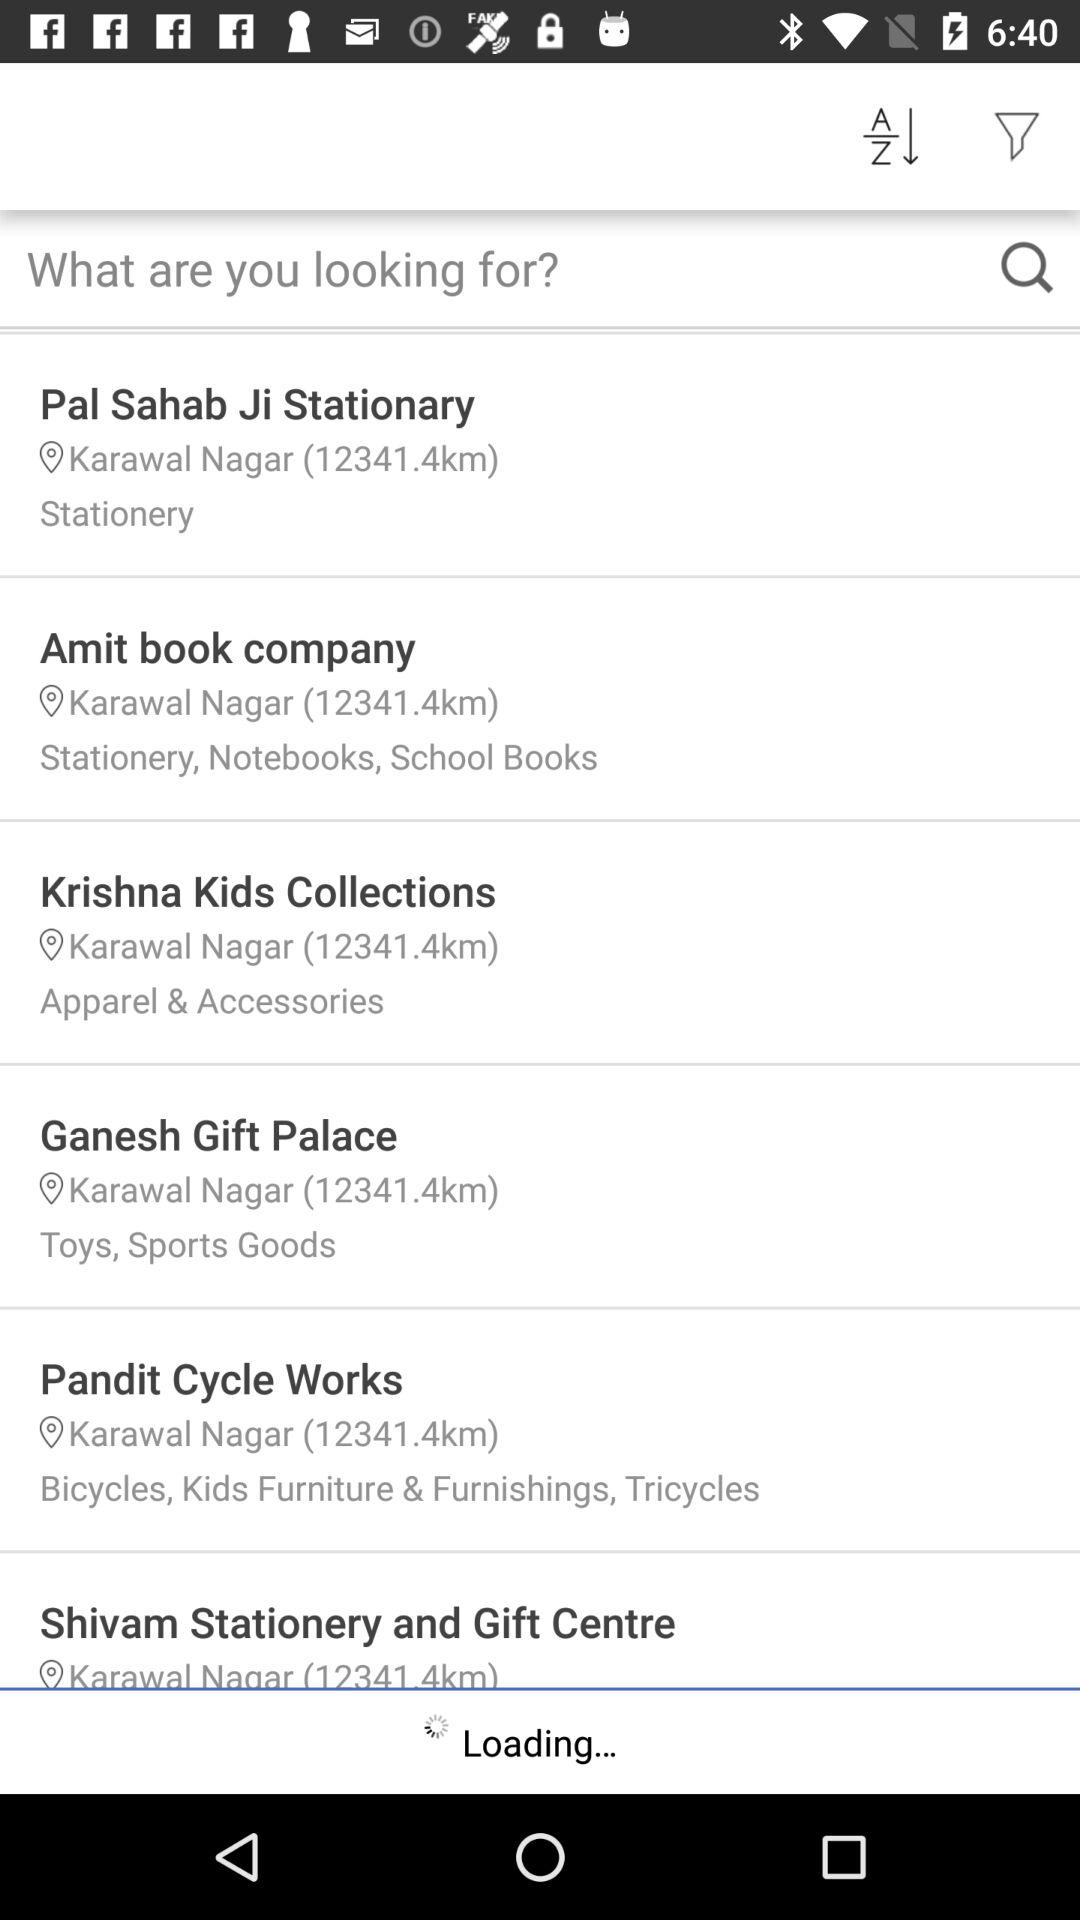How far is the "Krishna Kids Collections" from my location? "Krishna Kids Collections" is 12341.4 km from your location. 